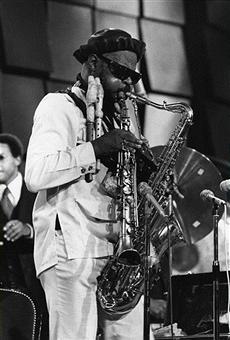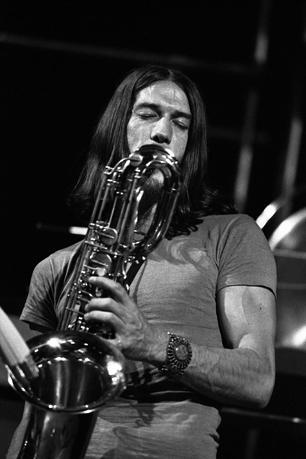The first image is the image on the left, the second image is the image on the right. Evaluate the accuracy of this statement regarding the images: "In one of the pictures a musician is wearing a hat.". Is it true? Answer yes or no. Yes. The first image is the image on the left, the second image is the image on the right. For the images displayed, is the sentence "An image shows a non-black man with bare forearms playing the sax." factually correct? Answer yes or no. Yes. 